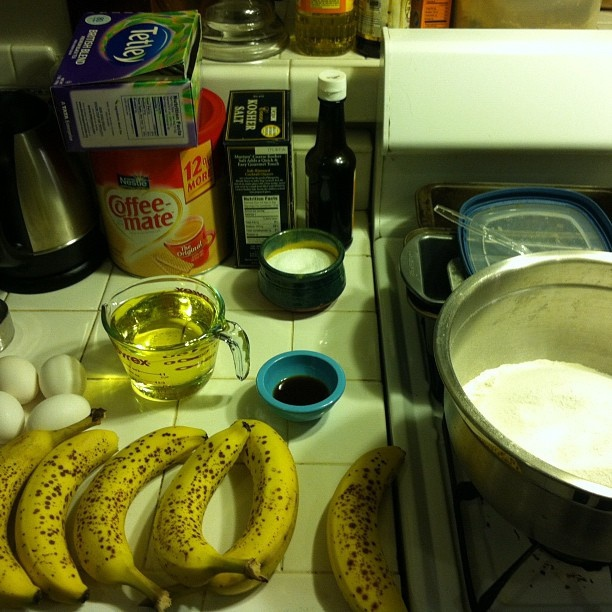Describe the objects in this image and their specific colors. I can see oven in black, lightyellow, and darkgreen tones, banana in black and olive tones, bowl in black, olive, lightyellow, and darkgreen tones, cup in black, olive, and khaki tones, and bowl in black, khaki, and darkgreen tones in this image. 